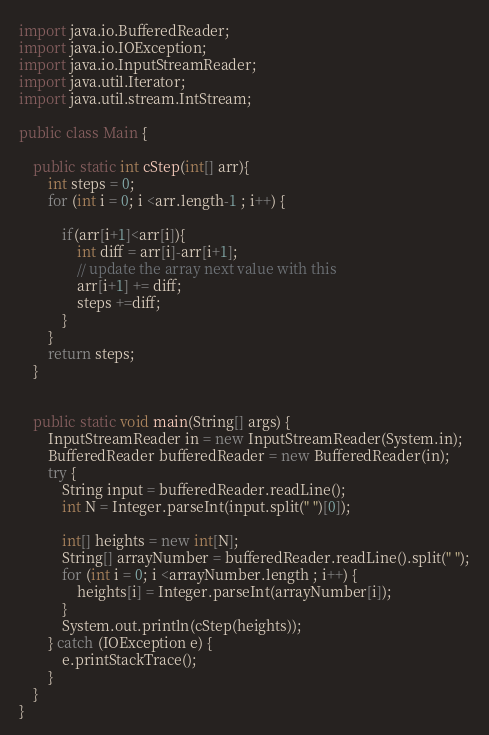Convert code to text. <code><loc_0><loc_0><loc_500><loc_500><_Java_>import java.io.BufferedReader;
import java.io.IOException;
import java.io.InputStreamReader;
import java.util.Iterator;
import java.util.stream.IntStream;

public class Main {

    public static int cStep(int[] arr){
        int steps = 0;
        for (int i = 0; i <arr.length-1 ; i++) {

            if(arr[i+1]<arr[i]){
                int diff = arr[i]-arr[i+1];
                // update the array next value with this
                arr[i+1] += diff;
                steps +=diff;
            }
        }
        return steps;
    }


    public static void main(String[] args) {
        InputStreamReader in = new InputStreamReader(System.in);
        BufferedReader bufferedReader = new BufferedReader(in);
        try {
            String input = bufferedReader.readLine();
            int N = Integer.parseInt(input.split(" ")[0]);

            int[] heights = new int[N];
            String[] arrayNumber = bufferedReader.readLine().split(" ");
            for (int i = 0; i <arrayNumber.length ; i++) {
                heights[i] = Integer.parseInt(arrayNumber[i]);
            }
            System.out.println(cStep(heights));
        } catch (IOException e) {
            e.printStackTrace();
        }
    }
}
</code> 